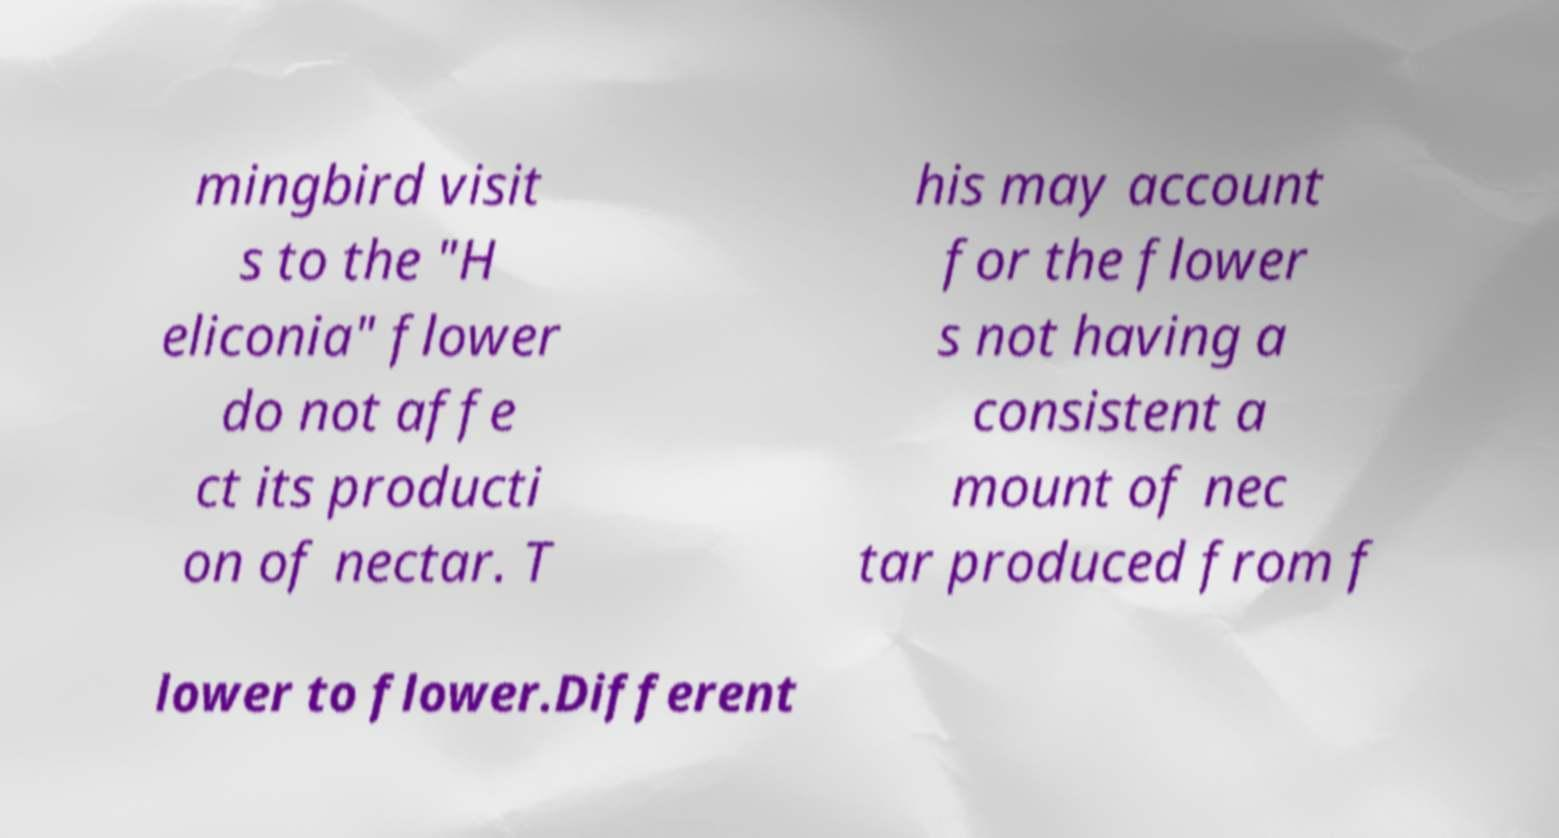Can you accurately transcribe the text from the provided image for me? mingbird visit s to the "H eliconia" flower do not affe ct its producti on of nectar. T his may account for the flower s not having a consistent a mount of nec tar produced from f lower to flower.Different 